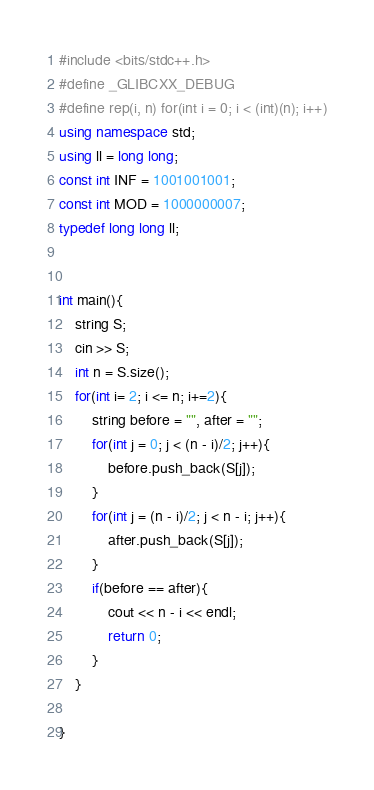Convert code to text. <code><loc_0><loc_0><loc_500><loc_500><_C++_>#include <bits/stdc++.h>
#define _GLIBCXX_DEBUG
#define rep(i, n) for(int i = 0; i < (int)(n); i++)
using namespace std;
using ll = long long;
const int INF = 1001001001;
const int MOD = 1000000007;
typedef long long ll;


int main(){
    string S;
    cin >> S;
    int n = S.size();
    for(int i= 2; i <= n; i+=2){
        string before = "", after = "";
        for(int j = 0; j < (n - i)/2; j++){
            before.push_back(S[j]);
        }
        for(int j = (n - i)/2; j < n - i; j++){
            after.push_back(S[j]);
        }
        if(before == after){
            cout << n - i << endl;
            return 0;
        }
    }

}
</code> 